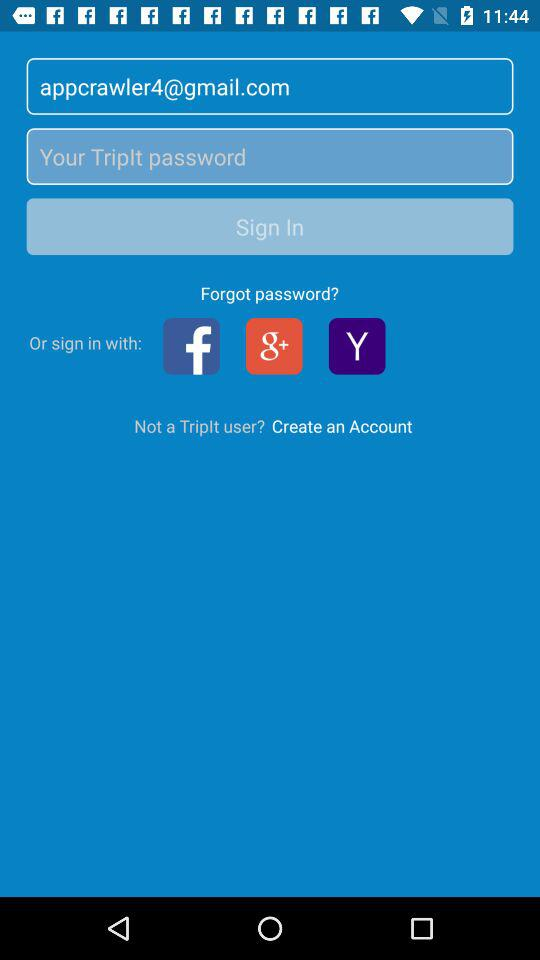What is the name of the application? The name of the application is "TripIt". 